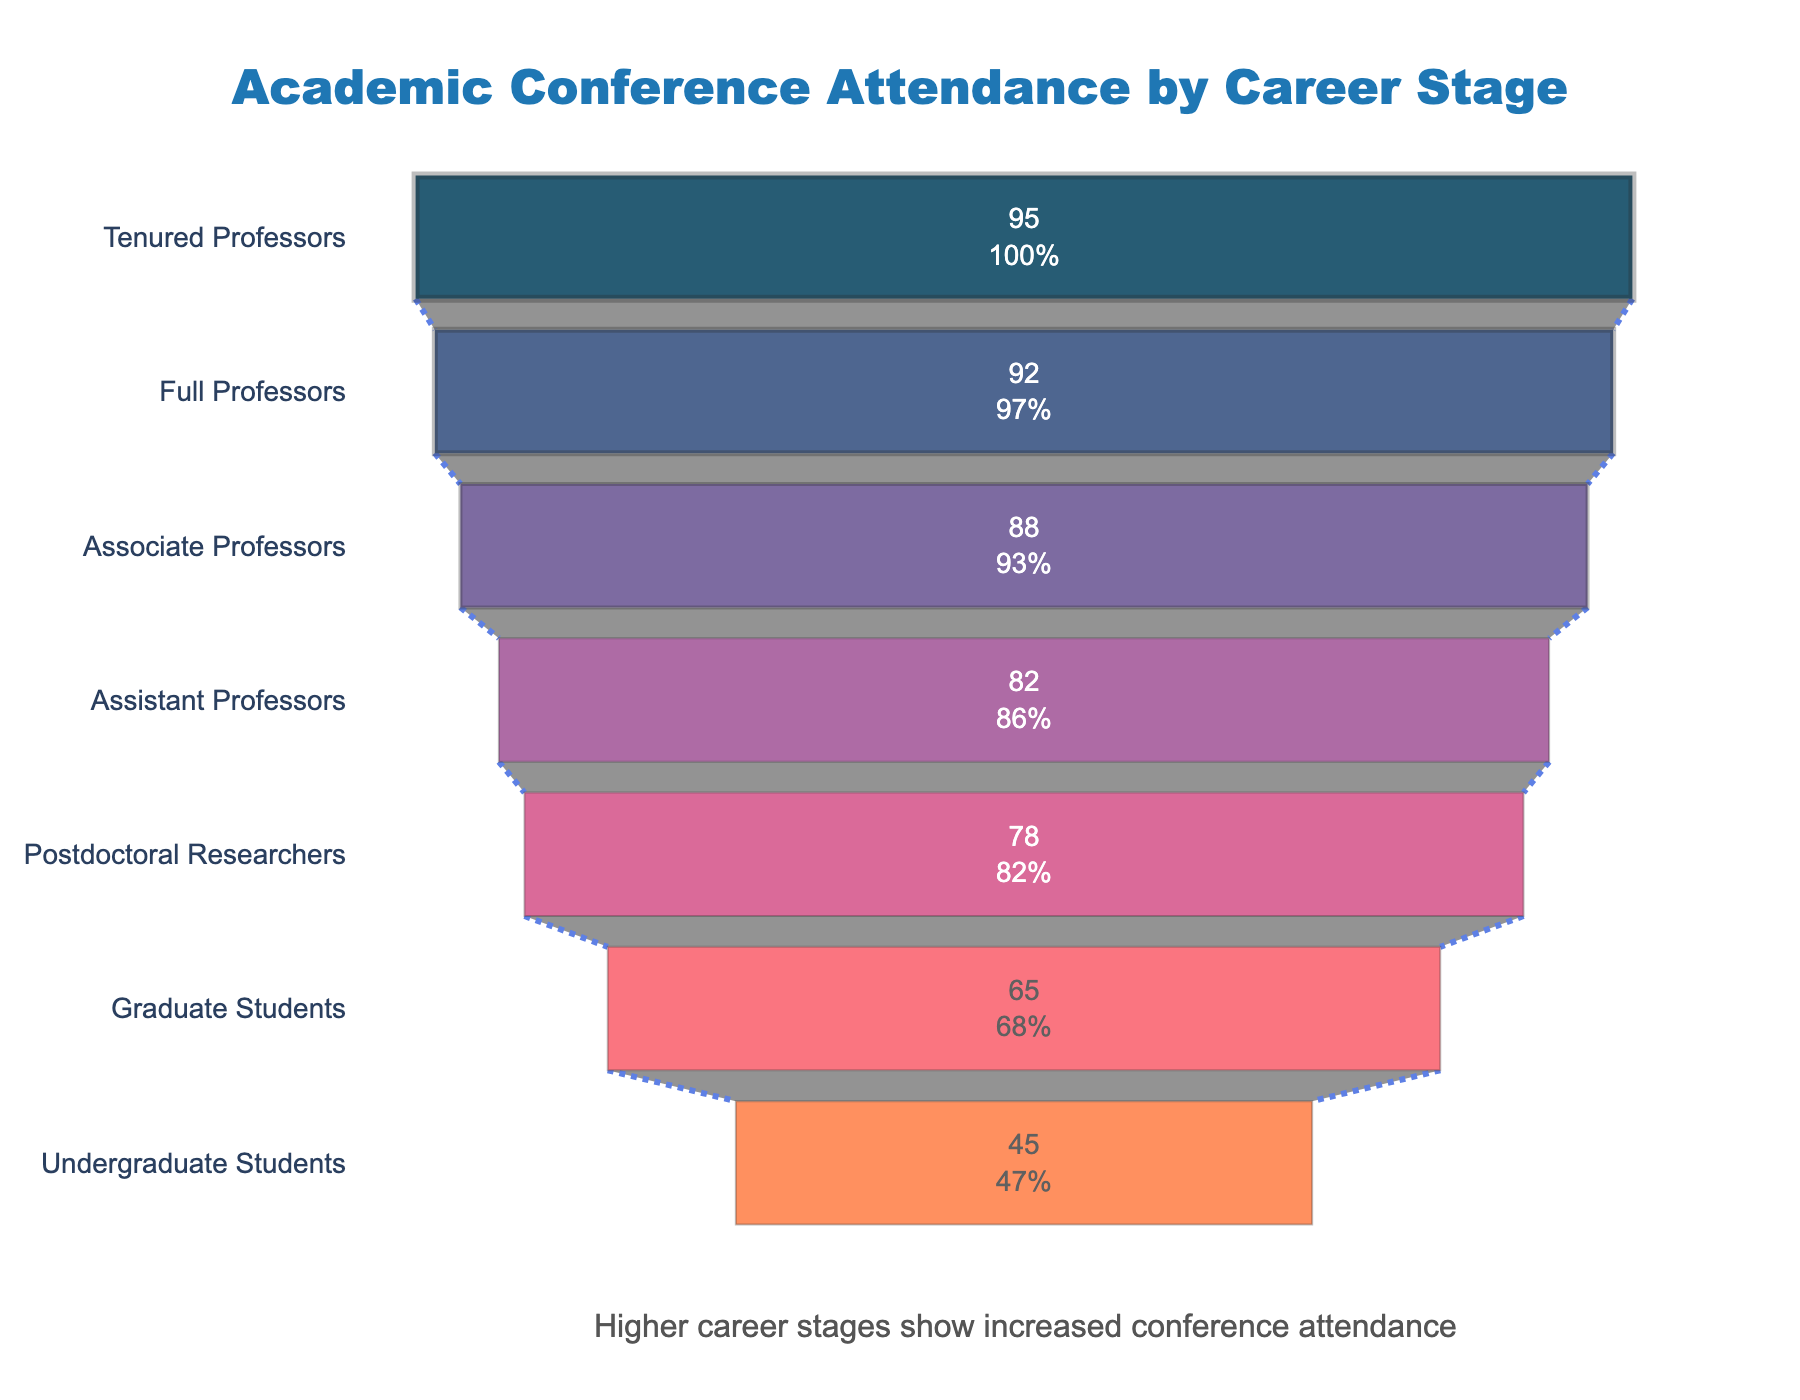What is the title of the figure? The title is usually at the top of the figure. In this case, it is "Academic Conference Attendance by Career Stage" as stated in the layout configuration.
Answer: Academic Conference Attendance by Career Stage How many career stages are represented in the figure? By counting the unique career stages on the y-axis, we see the figure represents "Undergraduate Students," "Graduate Students," "Postdoctoral Researchers," "Assistant Professors," "Associate Professors," "Full Professors," and "Tenured Professors" - seven stages in total.
Answer: Seven Which career stage has the highest attendance percentage? The career stage with the highest attendance is at the widest part of the funnel. Here, "Tenured Professors" have the highest percentage at 95%.
Answer: Tenured Professors What is the attendance percentage for Associate Professors? Find "Associate Professors" on the y-axis and refer to the corresponding section. It shows that attendance is 88%.
Answer: 88% How does the attendance of Graduate Students compare to Postdoctoral Researchers? Graduate Students have an attendance percentage of 65%, while Postdoctoral Researchers have 78%. Comparing these, Postdoctoral Researchers have a higher attendance percentage.
Answer: Postdoctoral Researchers have higher attendance than Graduate Students Calculate the average attendance percentage among all career stages. Sum all the attendance percentages (45 + 65 + 78 + 82 + 88 + 92 + 95) and divide by the number of stages (7). \( (45 + 65 + 78 + 82 + 88 + 92 + 95) / 7 = 77.86 \)
Answer: 77.86 What percentage of attendees are Full Professors? Referring to the y-axis for "Full Professors," the corresponding percentage is 92%.
Answer: 92% What is the increase in attendance percentage from Undergraduate Students to Assistant Professors? The attendance for Undergraduate Students is 45%, and for Assistant Professors, it is 82%. Calculating the difference: \( 82 - 45 = 37 \).
Answer: 37 Which career stage experienced the greatest increase in attendance percentage compared to the previous stage? Compare consecutive stages: 
Graduate to Postdoc (65 to 78 = 13), Postdoc to Assistant (78 to 82 = 4), Assistant to Associate (82 to 88 = 6), Associate to Full (88 to 92 = 4), Full to Tenured (92 to 95 = 3). The largest increase is from Graduate Students to Postdoctoral Researchers (13%).
Answer: Graduate to Postdoctoral Researchers What trend do you observe in the conference attendance as career stages advance? Examining the funnel, as the career advances from Undergraduate Students to Tenured Professors, the attendance percentage consistently increases.
Answer: Attendance increases with career stage 